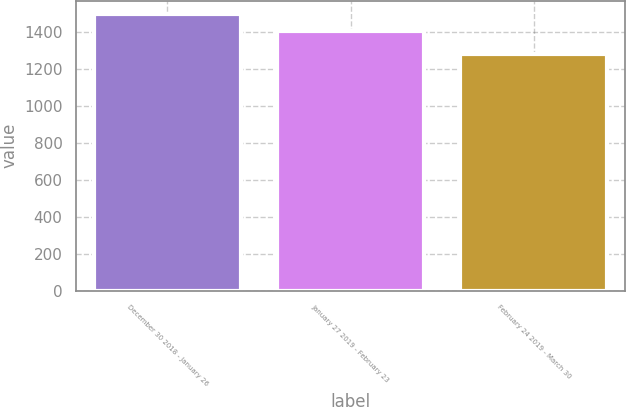Convert chart. <chart><loc_0><loc_0><loc_500><loc_500><bar_chart><fcel>December 30 2018 - January 26<fcel>January 27 2019 - February 23<fcel>February 24 2019 - March 30<nl><fcel>1498<fcel>1406<fcel>1285<nl></chart> 